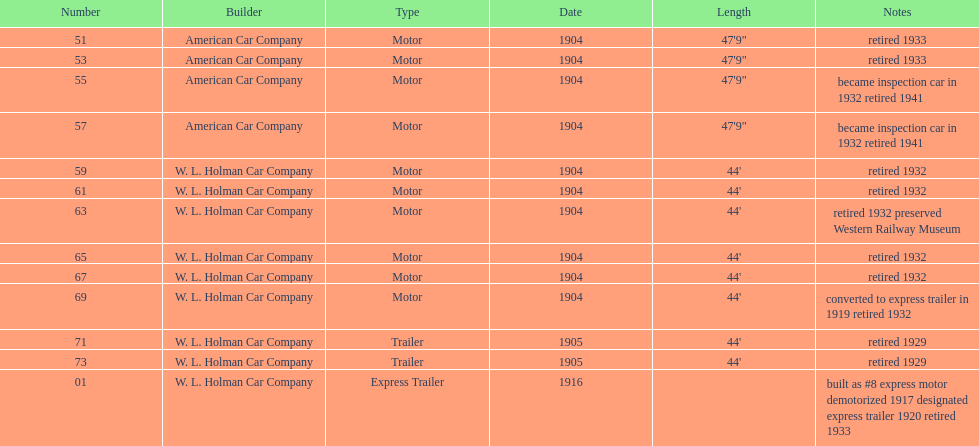Did american car company or w.l. holman car company build cars that were 44' in length? W. L. Holman Car Company. 